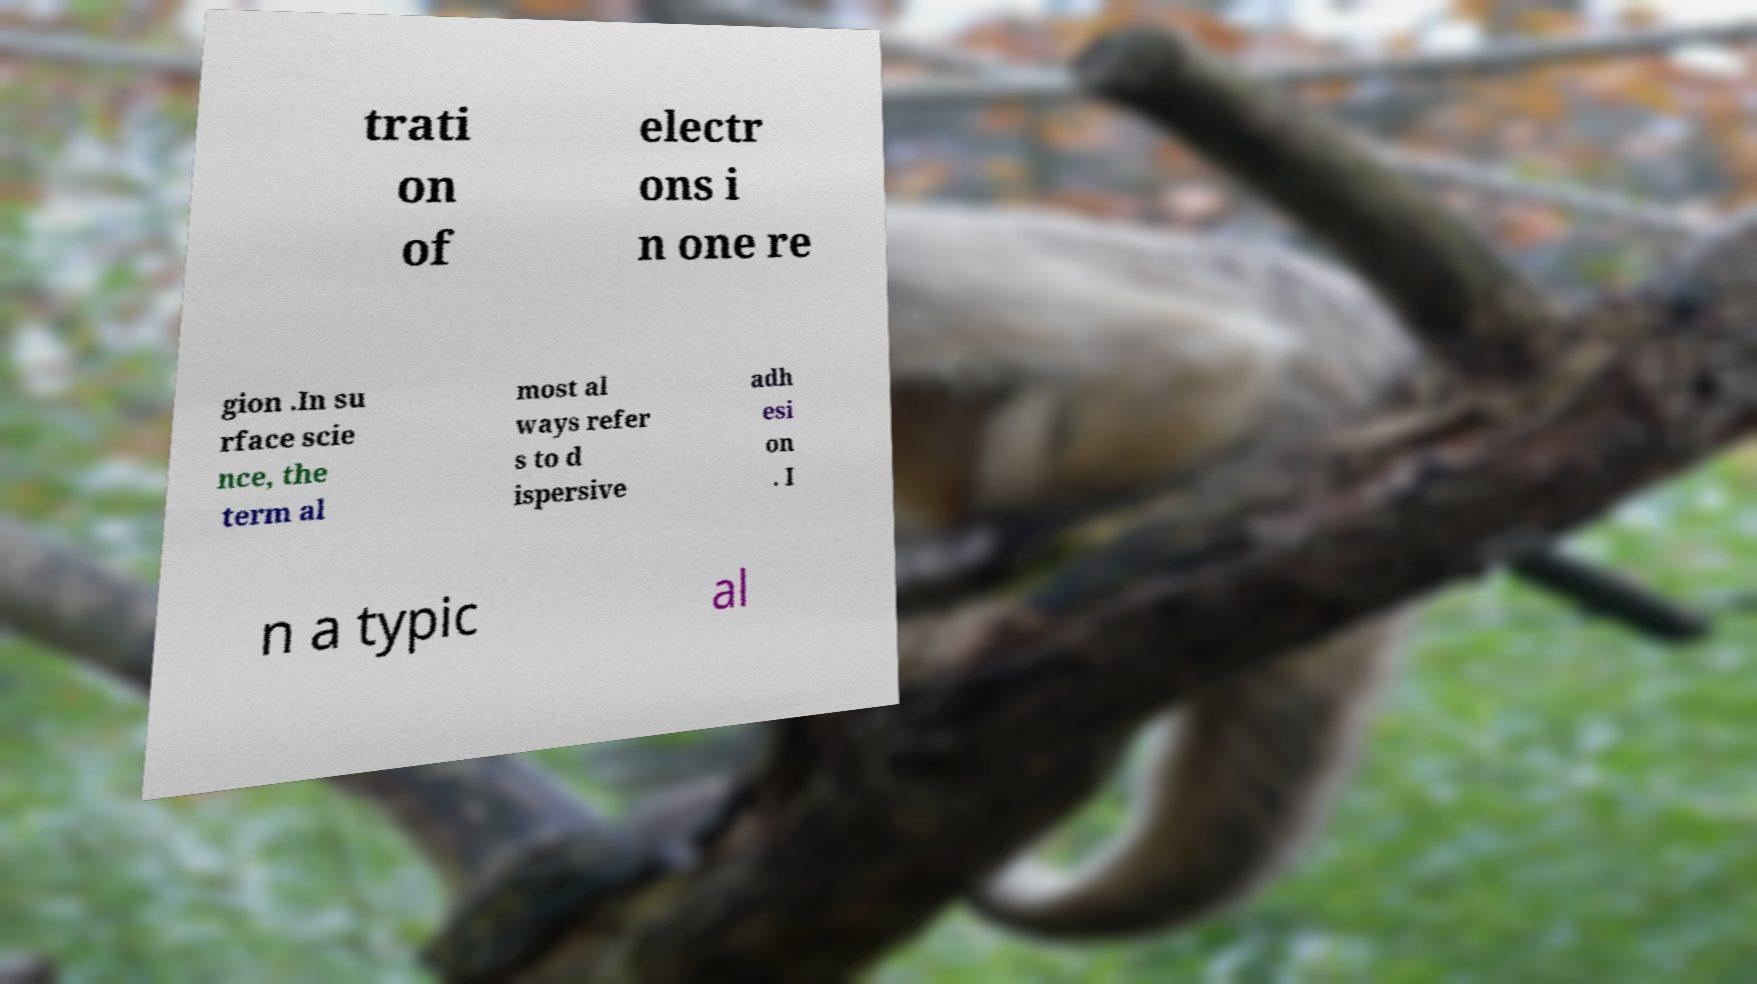Can you read and provide the text displayed in the image?This photo seems to have some interesting text. Can you extract and type it out for me? trati on of electr ons i n one re gion .In su rface scie nce, the term al most al ways refer s to d ispersive adh esi on . I n a typic al 